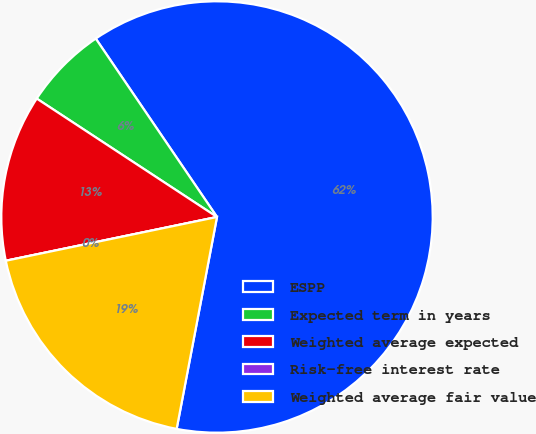<chart> <loc_0><loc_0><loc_500><loc_500><pie_chart><fcel>ESPP<fcel>Expected term in years<fcel>Weighted average expected<fcel>Risk-free interest rate<fcel>Weighted average fair value<nl><fcel>62.49%<fcel>6.25%<fcel>12.5%<fcel>0.0%<fcel>18.75%<nl></chart> 